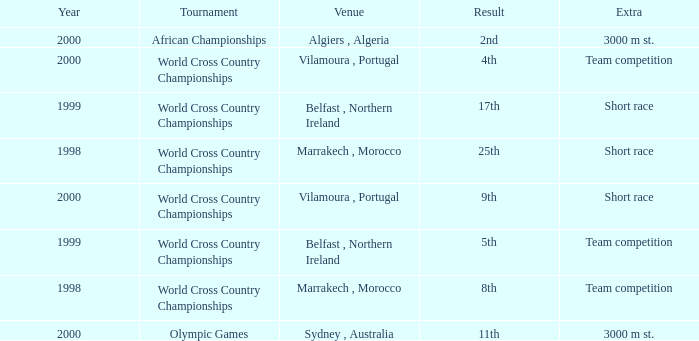Tell me the sum of year for 5th result 1999.0. 